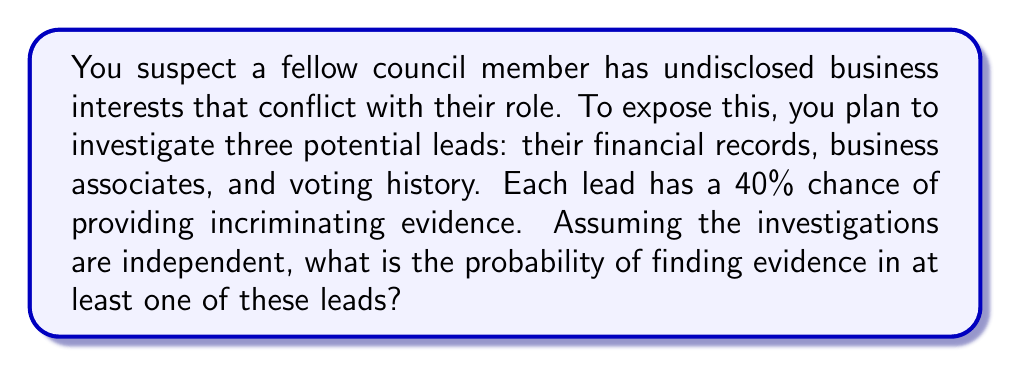Give your solution to this math problem. Let's approach this step-by-step:

1) First, we need to calculate the probability of not finding evidence in each lead. If the probability of finding evidence is 40% (or 0.4), then the probability of not finding evidence is:

   $1 - 0.4 = 0.6$ or 60%

2) Now, since the investigations are independent, we can use the multiplication rule of probability. The probability of not finding evidence in any of the three leads is:

   $0.6 \times 0.6 \times 0.6 = 0.6^3 = 0.216$

3) This means the probability of not finding any evidence is 0.216 or 21.6%

4) Therefore, the probability of finding evidence in at least one lead is the complement of this probability:

   $1 - 0.216 = 0.784$

5) We can also derive this using the formula for the probability of at least one success in n independent trials:

   $$P(\text{at least one success}) = 1 - (1-p)^n$$

   Where $p$ is the probability of success in each trial and $n$ is the number of trials.

   In this case, $p = 0.4$ and $n = 3$:

   $$1 - (1-0.4)^3 = 1 - 0.6^3 = 1 - 0.216 = 0.784$$
Answer: 0.784 or 78.4% 